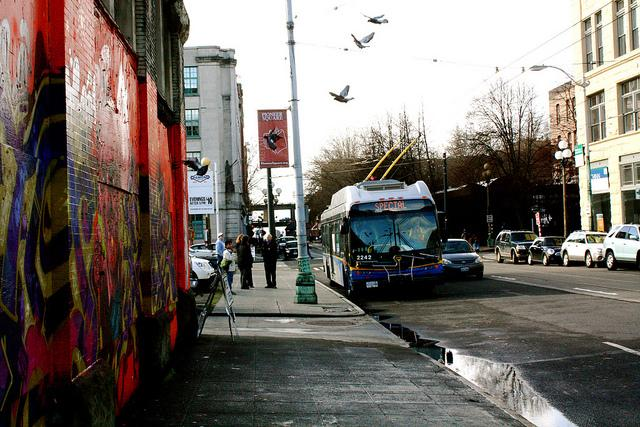What color are the birds flying over the street?

Choices:
A) white
B) black
C) gray
D) brown gray 